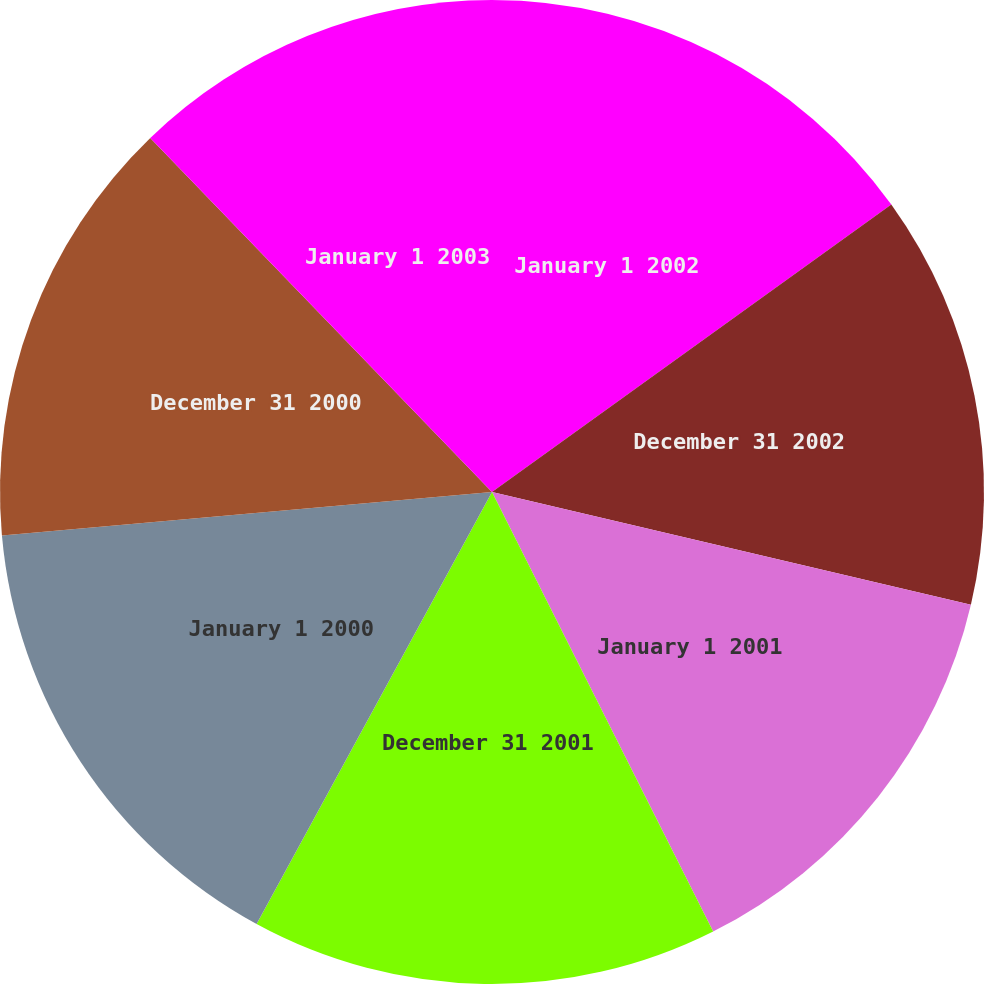<chart> <loc_0><loc_0><loc_500><loc_500><pie_chart><fcel>January 1 2002<fcel>December 31 2002<fcel>January 1 2001<fcel>December 31 2001<fcel>January 1 2000<fcel>December 31 2000<fcel>January 1 2003<nl><fcel>15.07%<fcel>13.61%<fcel>13.9%<fcel>15.36%<fcel>15.65%<fcel>14.19%<fcel>12.22%<nl></chart> 